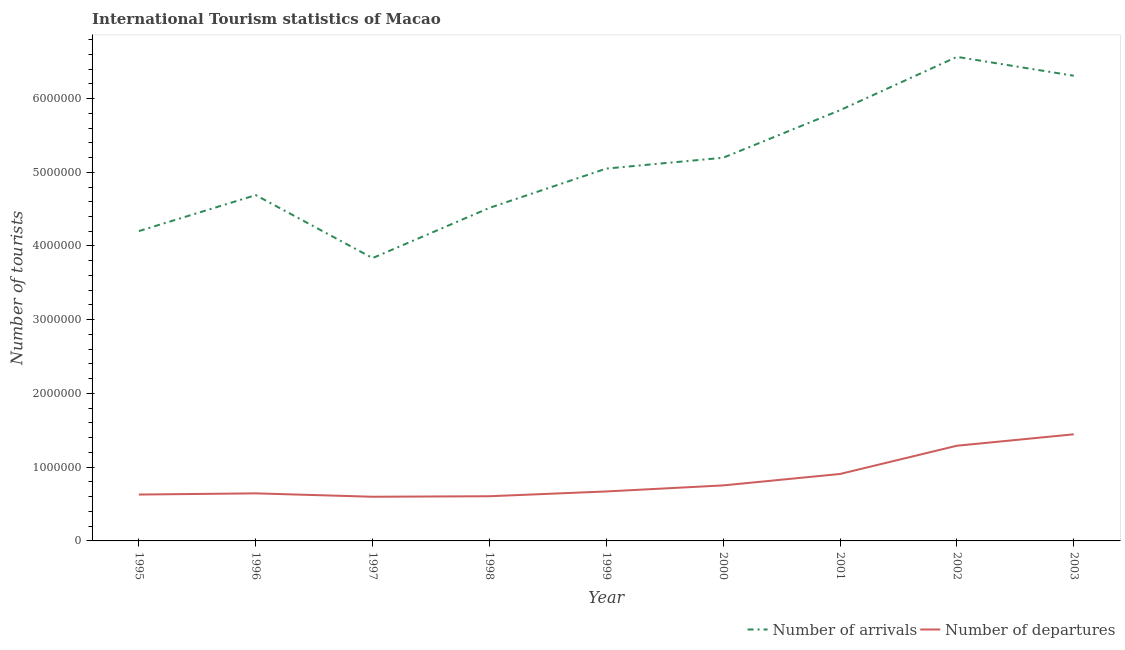How many different coloured lines are there?
Make the answer very short. 2. Does the line corresponding to number of tourist arrivals intersect with the line corresponding to number of tourist departures?
Offer a very short reply. No. What is the number of tourist arrivals in 1996?
Keep it short and to the point. 4.69e+06. Across all years, what is the maximum number of tourist arrivals?
Your answer should be compact. 6.56e+06. Across all years, what is the minimum number of tourist arrivals?
Give a very brief answer. 3.84e+06. In which year was the number of tourist arrivals maximum?
Keep it short and to the point. 2002. In which year was the number of tourist departures minimum?
Your response must be concise. 1997. What is the total number of tourist arrivals in the graph?
Make the answer very short. 4.62e+07. What is the difference between the number of tourist arrivals in 1995 and that in 1999?
Provide a succinct answer. -8.48e+05. What is the difference between the number of tourist arrivals in 1996 and the number of tourist departures in 1995?
Offer a terse response. 4.06e+06. What is the average number of tourist departures per year?
Your response must be concise. 8.39e+05. In the year 1997, what is the difference between the number of tourist departures and number of tourist arrivals?
Your answer should be very brief. -3.24e+06. In how many years, is the number of tourist departures greater than 1800000?
Your answer should be very brief. 0. What is the ratio of the number of tourist departures in 2000 to that in 2003?
Give a very brief answer. 0.52. Is the number of tourist departures in 1996 less than that in 2000?
Make the answer very short. Yes. What is the difference between the highest and the second highest number of tourist arrivals?
Provide a succinct answer. 2.56e+05. What is the difference between the highest and the lowest number of tourist departures?
Your answer should be compact. 8.47e+05. In how many years, is the number of tourist departures greater than the average number of tourist departures taken over all years?
Give a very brief answer. 3. Is the number of tourist departures strictly less than the number of tourist arrivals over the years?
Provide a succinct answer. Yes. What is the difference between two consecutive major ticks on the Y-axis?
Provide a short and direct response. 1.00e+06. Are the values on the major ticks of Y-axis written in scientific E-notation?
Provide a short and direct response. No. Does the graph contain any zero values?
Give a very brief answer. No. Where does the legend appear in the graph?
Your response must be concise. Bottom right. How many legend labels are there?
Offer a very short reply. 2. What is the title of the graph?
Keep it short and to the point. International Tourism statistics of Macao. Does "Infant" appear as one of the legend labels in the graph?
Make the answer very short. No. What is the label or title of the X-axis?
Offer a terse response. Year. What is the label or title of the Y-axis?
Offer a very short reply. Number of tourists. What is the Number of tourists of Number of arrivals in 1995?
Give a very brief answer. 4.20e+06. What is the Number of tourists of Number of departures in 1995?
Your answer should be compact. 6.29e+05. What is the Number of tourists in Number of arrivals in 1996?
Your answer should be compact. 4.69e+06. What is the Number of tourists of Number of departures in 1996?
Keep it short and to the point. 6.45e+05. What is the Number of tourists of Number of arrivals in 1997?
Provide a short and direct response. 3.84e+06. What is the Number of tourists of Number of departures in 1997?
Your answer should be compact. 5.99e+05. What is the Number of tourists in Number of arrivals in 1998?
Provide a succinct answer. 4.52e+06. What is the Number of tourists of Number of departures in 1998?
Provide a short and direct response. 6.06e+05. What is the Number of tourists of Number of arrivals in 1999?
Provide a succinct answer. 5.05e+06. What is the Number of tourists in Number of departures in 1999?
Make the answer very short. 6.71e+05. What is the Number of tourists of Number of arrivals in 2000?
Offer a very short reply. 5.20e+06. What is the Number of tourists in Number of departures in 2000?
Provide a short and direct response. 7.53e+05. What is the Number of tourists of Number of arrivals in 2001?
Provide a succinct answer. 5.84e+06. What is the Number of tourists of Number of departures in 2001?
Your answer should be compact. 9.08e+05. What is the Number of tourists in Number of arrivals in 2002?
Your answer should be very brief. 6.56e+06. What is the Number of tourists in Number of departures in 2002?
Make the answer very short. 1.29e+06. What is the Number of tourists of Number of arrivals in 2003?
Offer a very short reply. 6.31e+06. What is the Number of tourists of Number of departures in 2003?
Keep it short and to the point. 1.45e+06. Across all years, what is the maximum Number of tourists of Number of arrivals?
Offer a terse response. 6.56e+06. Across all years, what is the maximum Number of tourists of Number of departures?
Your answer should be very brief. 1.45e+06. Across all years, what is the minimum Number of tourists in Number of arrivals?
Keep it short and to the point. 3.84e+06. Across all years, what is the minimum Number of tourists of Number of departures?
Offer a very short reply. 5.99e+05. What is the total Number of tourists in Number of arrivals in the graph?
Your answer should be very brief. 4.62e+07. What is the total Number of tourists in Number of departures in the graph?
Keep it short and to the point. 7.55e+06. What is the difference between the Number of tourists in Number of arrivals in 1995 and that in 1996?
Provide a succinct answer. -4.88e+05. What is the difference between the Number of tourists of Number of departures in 1995 and that in 1996?
Your answer should be compact. -1.60e+04. What is the difference between the Number of tourists in Number of arrivals in 1995 and that in 1997?
Offer a terse response. 3.66e+05. What is the difference between the Number of tourists of Number of arrivals in 1995 and that in 1998?
Give a very brief answer. -3.15e+05. What is the difference between the Number of tourists of Number of departures in 1995 and that in 1998?
Ensure brevity in your answer.  2.30e+04. What is the difference between the Number of tourists of Number of arrivals in 1995 and that in 1999?
Your answer should be compact. -8.48e+05. What is the difference between the Number of tourists in Number of departures in 1995 and that in 1999?
Your response must be concise. -4.20e+04. What is the difference between the Number of tourists of Number of arrivals in 1995 and that in 2000?
Offer a very short reply. -9.95e+05. What is the difference between the Number of tourists of Number of departures in 1995 and that in 2000?
Offer a terse response. -1.24e+05. What is the difference between the Number of tourists in Number of arrivals in 1995 and that in 2001?
Your answer should be very brief. -1.64e+06. What is the difference between the Number of tourists in Number of departures in 1995 and that in 2001?
Your answer should be compact. -2.79e+05. What is the difference between the Number of tourists of Number of arrivals in 1995 and that in 2002?
Offer a very short reply. -2.36e+06. What is the difference between the Number of tourists of Number of departures in 1995 and that in 2002?
Your answer should be compact. -6.62e+05. What is the difference between the Number of tourists in Number of arrivals in 1995 and that in 2003?
Your answer should be compact. -2.11e+06. What is the difference between the Number of tourists in Number of departures in 1995 and that in 2003?
Your answer should be compact. -8.17e+05. What is the difference between the Number of tourists of Number of arrivals in 1996 and that in 1997?
Provide a succinct answer. 8.54e+05. What is the difference between the Number of tourists of Number of departures in 1996 and that in 1997?
Your answer should be very brief. 4.60e+04. What is the difference between the Number of tourists of Number of arrivals in 1996 and that in 1998?
Provide a short and direct response. 1.73e+05. What is the difference between the Number of tourists in Number of departures in 1996 and that in 1998?
Your answer should be very brief. 3.90e+04. What is the difference between the Number of tourists of Number of arrivals in 1996 and that in 1999?
Your answer should be compact. -3.60e+05. What is the difference between the Number of tourists in Number of departures in 1996 and that in 1999?
Offer a very short reply. -2.60e+04. What is the difference between the Number of tourists in Number of arrivals in 1996 and that in 2000?
Provide a succinct answer. -5.07e+05. What is the difference between the Number of tourists in Number of departures in 1996 and that in 2000?
Make the answer very short. -1.08e+05. What is the difference between the Number of tourists of Number of arrivals in 1996 and that in 2001?
Offer a very short reply. -1.15e+06. What is the difference between the Number of tourists of Number of departures in 1996 and that in 2001?
Offer a terse response. -2.63e+05. What is the difference between the Number of tourists in Number of arrivals in 1996 and that in 2002?
Your answer should be very brief. -1.88e+06. What is the difference between the Number of tourists of Number of departures in 1996 and that in 2002?
Keep it short and to the point. -6.46e+05. What is the difference between the Number of tourists in Number of arrivals in 1996 and that in 2003?
Your response must be concise. -1.62e+06. What is the difference between the Number of tourists of Number of departures in 1996 and that in 2003?
Keep it short and to the point. -8.01e+05. What is the difference between the Number of tourists in Number of arrivals in 1997 and that in 1998?
Provide a short and direct response. -6.81e+05. What is the difference between the Number of tourists of Number of departures in 1997 and that in 1998?
Provide a succinct answer. -7000. What is the difference between the Number of tourists of Number of arrivals in 1997 and that in 1999?
Your answer should be compact. -1.21e+06. What is the difference between the Number of tourists of Number of departures in 1997 and that in 1999?
Offer a very short reply. -7.20e+04. What is the difference between the Number of tourists in Number of arrivals in 1997 and that in 2000?
Ensure brevity in your answer.  -1.36e+06. What is the difference between the Number of tourists of Number of departures in 1997 and that in 2000?
Your answer should be very brief. -1.54e+05. What is the difference between the Number of tourists in Number of arrivals in 1997 and that in 2001?
Provide a succinct answer. -2.01e+06. What is the difference between the Number of tourists in Number of departures in 1997 and that in 2001?
Ensure brevity in your answer.  -3.09e+05. What is the difference between the Number of tourists in Number of arrivals in 1997 and that in 2002?
Keep it short and to the point. -2.73e+06. What is the difference between the Number of tourists in Number of departures in 1997 and that in 2002?
Your answer should be very brief. -6.92e+05. What is the difference between the Number of tourists in Number of arrivals in 1997 and that in 2003?
Ensure brevity in your answer.  -2.47e+06. What is the difference between the Number of tourists in Number of departures in 1997 and that in 2003?
Provide a short and direct response. -8.47e+05. What is the difference between the Number of tourists in Number of arrivals in 1998 and that in 1999?
Provide a succinct answer. -5.33e+05. What is the difference between the Number of tourists in Number of departures in 1998 and that in 1999?
Offer a very short reply. -6.50e+04. What is the difference between the Number of tourists of Number of arrivals in 1998 and that in 2000?
Keep it short and to the point. -6.80e+05. What is the difference between the Number of tourists in Number of departures in 1998 and that in 2000?
Your answer should be very brief. -1.47e+05. What is the difference between the Number of tourists in Number of arrivals in 1998 and that in 2001?
Your answer should be compact. -1.32e+06. What is the difference between the Number of tourists of Number of departures in 1998 and that in 2001?
Provide a succinct answer. -3.02e+05. What is the difference between the Number of tourists of Number of arrivals in 1998 and that in 2002?
Ensure brevity in your answer.  -2.05e+06. What is the difference between the Number of tourists in Number of departures in 1998 and that in 2002?
Make the answer very short. -6.85e+05. What is the difference between the Number of tourists of Number of arrivals in 1998 and that in 2003?
Ensure brevity in your answer.  -1.79e+06. What is the difference between the Number of tourists of Number of departures in 1998 and that in 2003?
Provide a succinct answer. -8.40e+05. What is the difference between the Number of tourists of Number of arrivals in 1999 and that in 2000?
Your answer should be compact. -1.47e+05. What is the difference between the Number of tourists of Number of departures in 1999 and that in 2000?
Your answer should be compact. -8.20e+04. What is the difference between the Number of tourists in Number of arrivals in 1999 and that in 2001?
Offer a terse response. -7.92e+05. What is the difference between the Number of tourists in Number of departures in 1999 and that in 2001?
Your answer should be compact. -2.37e+05. What is the difference between the Number of tourists of Number of arrivals in 1999 and that in 2002?
Provide a short and direct response. -1.52e+06. What is the difference between the Number of tourists in Number of departures in 1999 and that in 2002?
Offer a very short reply. -6.20e+05. What is the difference between the Number of tourists of Number of arrivals in 1999 and that in 2003?
Provide a short and direct response. -1.26e+06. What is the difference between the Number of tourists of Number of departures in 1999 and that in 2003?
Ensure brevity in your answer.  -7.75e+05. What is the difference between the Number of tourists in Number of arrivals in 2000 and that in 2001?
Provide a short and direct response. -6.45e+05. What is the difference between the Number of tourists in Number of departures in 2000 and that in 2001?
Your answer should be very brief. -1.55e+05. What is the difference between the Number of tourists of Number of arrivals in 2000 and that in 2002?
Make the answer very short. -1.37e+06. What is the difference between the Number of tourists of Number of departures in 2000 and that in 2002?
Give a very brief answer. -5.38e+05. What is the difference between the Number of tourists of Number of arrivals in 2000 and that in 2003?
Provide a succinct answer. -1.11e+06. What is the difference between the Number of tourists in Number of departures in 2000 and that in 2003?
Ensure brevity in your answer.  -6.93e+05. What is the difference between the Number of tourists of Number of arrivals in 2001 and that in 2002?
Provide a succinct answer. -7.23e+05. What is the difference between the Number of tourists in Number of departures in 2001 and that in 2002?
Your answer should be very brief. -3.83e+05. What is the difference between the Number of tourists in Number of arrivals in 2001 and that in 2003?
Give a very brief answer. -4.67e+05. What is the difference between the Number of tourists of Number of departures in 2001 and that in 2003?
Give a very brief answer. -5.38e+05. What is the difference between the Number of tourists in Number of arrivals in 2002 and that in 2003?
Give a very brief answer. 2.56e+05. What is the difference between the Number of tourists of Number of departures in 2002 and that in 2003?
Your answer should be very brief. -1.55e+05. What is the difference between the Number of tourists in Number of arrivals in 1995 and the Number of tourists in Number of departures in 1996?
Keep it short and to the point. 3.56e+06. What is the difference between the Number of tourists in Number of arrivals in 1995 and the Number of tourists in Number of departures in 1997?
Give a very brief answer. 3.60e+06. What is the difference between the Number of tourists of Number of arrivals in 1995 and the Number of tourists of Number of departures in 1998?
Ensure brevity in your answer.  3.60e+06. What is the difference between the Number of tourists of Number of arrivals in 1995 and the Number of tourists of Number of departures in 1999?
Provide a succinct answer. 3.53e+06. What is the difference between the Number of tourists of Number of arrivals in 1995 and the Number of tourists of Number of departures in 2000?
Offer a very short reply. 3.45e+06. What is the difference between the Number of tourists of Number of arrivals in 1995 and the Number of tourists of Number of departures in 2001?
Your answer should be very brief. 3.29e+06. What is the difference between the Number of tourists in Number of arrivals in 1995 and the Number of tourists in Number of departures in 2002?
Provide a short and direct response. 2.91e+06. What is the difference between the Number of tourists in Number of arrivals in 1995 and the Number of tourists in Number of departures in 2003?
Make the answer very short. 2.76e+06. What is the difference between the Number of tourists in Number of arrivals in 1996 and the Number of tourists in Number of departures in 1997?
Your response must be concise. 4.09e+06. What is the difference between the Number of tourists in Number of arrivals in 1996 and the Number of tourists in Number of departures in 1998?
Offer a very short reply. 4.08e+06. What is the difference between the Number of tourists in Number of arrivals in 1996 and the Number of tourists in Number of departures in 1999?
Your response must be concise. 4.02e+06. What is the difference between the Number of tourists in Number of arrivals in 1996 and the Number of tourists in Number of departures in 2000?
Ensure brevity in your answer.  3.94e+06. What is the difference between the Number of tourists of Number of arrivals in 1996 and the Number of tourists of Number of departures in 2001?
Provide a succinct answer. 3.78e+06. What is the difference between the Number of tourists of Number of arrivals in 1996 and the Number of tourists of Number of departures in 2002?
Your response must be concise. 3.40e+06. What is the difference between the Number of tourists of Number of arrivals in 1996 and the Number of tourists of Number of departures in 2003?
Provide a succinct answer. 3.24e+06. What is the difference between the Number of tourists in Number of arrivals in 1997 and the Number of tourists in Number of departures in 1998?
Offer a very short reply. 3.23e+06. What is the difference between the Number of tourists of Number of arrivals in 1997 and the Number of tourists of Number of departures in 1999?
Provide a succinct answer. 3.16e+06. What is the difference between the Number of tourists in Number of arrivals in 1997 and the Number of tourists in Number of departures in 2000?
Provide a short and direct response. 3.08e+06. What is the difference between the Number of tourists of Number of arrivals in 1997 and the Number of tourists of Number of departures in 2001?
Ensure brevity in your answer.  2.93e+06. What is the difference between the Number of tourists in Number of arrivals in 1997 and the Number of tourists in Number of departures in 2002?
Your response must be concise. 2.54e+06. What is the difference between the Number of tourists in Number of arrivals in 1997 and the Number of tourists in Number of departures in 2003?
Provide a succinct answer. 2.39e+06. What is the difference between the Number of tourists in Number of arrivals in 1998 and the Number of tourists in Number of departures in 1999?
Your answer should be compact. 3.85e+06. What is the difference between the Number of tourists in Number of arrivals in 1998 and the Number of tourists in Number of departures in 2000?
Provide a succinct answer. 3.76e+06. What is the difference between the Number of tourists of Number of arrivals in 1998 and the Number of tourists of Number of departures in 2001?
Make the answer very short. 3.61e+06. What is the difference between the Number of tourists in Number of arrivals in 1998 and the Number of tourists in Number of departures in 2002?
Provide a short and direct response. 3.23e+06. What is the difference between the Number of tourists of Number of arrivals in 1998 and the Number of tourists of Number of departures in 2003?
Make the answer very short. 3.07e+06. What is the difference between the Number of tourists in Number of arrivals in 1999 and the Number of tourists in Number of departures in 2000?
Ensure brevity in your answer.  4.30e+06. What is the difference between the Number of tourists in Number of arrivals in 1999 and the Number of tourists in Number of departures in 2001?
Keep it short and to the point. 4.14e+06. What is the difference between the Number of tourists of Number of arrivals in 1999 and the Number of tourists of Number of departures in 2002?
Provide a succinct answer. 3.76e+06. What is the difference between the Number of tourists of Number of arrivals in 1999 and the Number of tourists of Number of departures in 2003?
Your answer should be compact. 3.60e+06. What is the difference between the Number of tourists of Number of arrivals in 2000 and the Number of tourists of Number of departures in 2001?
Provide a succinct answer. 4.29e+06. What is the difference between the Number of tourists in Number of arrivals in 2000 and the Number of tourists in Number of departures in 2002?
Provide a succinct answer. 3.91e+06. What is the difference between the Number of tourists of Number of arrivals in 2000 and the Number of tourists of Number of departures in 2003?
Provide a short and direct response. 3.75e+06. What is the difference between the Number of tourists of Number of arrivals in 2001 and the Number of tourists of Number of departures in 2002?
Give a very brief answer. 4.55e+06. What is the difference between the Number of tourists in Number of arrivals in 2001 and the Number of tourists in Number of departures in 2003?
Your response must be concise. 4.40e+06. What is the difference between the Number of tourists in Number of arrivals in 2002 and the Number of tourists in Number of departures in 2003?
Make the answer very short. 5.12e+06. What is the average Number of tourists in Number of arrivals per year?
Offer a very short reply. 5.13e+06. What is the average Number of tourists of Number of departures per year?
Ensure brevity in your answer.  8.39e+05. In the year 1995, what is the difference between the Number of tourists of Number of arrivals and Number of tourists of Number of departures?
Give a very brief answer. 3.57e+06. In the year 1996, what is the difference between the Number of tourists in Number of arrivals and Number of tourists in Number of departures?
Keep it short and to the point. 4.04e+06. In the year 1997, what is the difference between the Number of tourists of Number of arrivals and Number of tourists of Number of departures?
Your answer should be compact. 3.24e+06. In the year 1998, what is the difference between the Number of tourists of Number of arrivals and Number of tourists of Number of departures?
Your response must be concise. 3.91e+06. In the year 1999, what is the difference between the Number of tourists in Number of arrivals and Number of tourists in Number of departures?
Provide a short and direct response. 4.38e+06. In the year 2000, what is the difference between the Number of tourists of Number of arrivals and Number of tourists of Number of departures?
Offer a very short reply. 4.44e+06. In the year 2001, what is the difference between the Number of tourists in Number of arrivals and Number of tourists in Number of departures?
Make the answer very short. 4.93e+06. In the year 2002, what is the difference between the Number of tourists in Number of arrivals and Number of tourists in Number of departures?
Offer a terse response. 5.27e+06. In the year 2003, what is the difference between the Number of tourists in Number of arrivals and Number of tourists in Number of departures?
Your answer should be very brief. 4.86e+06. What is the ratio of the Number of tourists of Number of arrivals in 1995 to that in 1996?
Offer a terse response. 0.9. What is the ratio of the Number of tourists of Number of departures in 1995 to that in 1996?
Your response must be concise. 0.98. What is the ratio of the Number of tourists in Number of arrivals in 1995 to that in 1997?
Provide a short and direct response. 1.1. What is the ratio of the Number of tourists of Number of departures in 1995 to that in 1997?
Provide a succinct answer. 1.05. What is the ratio of the Number of tourists of Number of arrivals in 1995 to that in 1998?
Your answer should be compact. 0.93. What is the ratio of the Number of tourists of Number of departures in 1995 to that in 1998?
Keep it short and to the point. 1.04. What is the ratio of the Number of tourists of Number of arrivals in 1995 to that in 1999?
Offer a terse response. 0.83. What is the ratio of the Number of tourists in Number of departures in 1995 to that in 1999?
Offer a very short reply. 0.94. What is the ratio of the Number of tourists in Number of arrivals in 1995 to that in 2000?
Your answer should be very brief. 0.81. What is the ratio of the Number of tourists in Number of departures in 1995 to that in 2000?
Your answer should be compact. 0.84. What is the ratio of the Number of tourists of Number of arrivals in 1995 to that in 2001?
Offer a terse response. 0.72. What is the ratio of the Number of tourists in Number of departures in 1995 to that in 2001?
Give a very brief answer. 0.69. What is the ratio of the Number of tourists in Number of arrivals in 1995 to that in 2002?
Your response must be concise. 0.64. What is the ratio of the Number of tourists of Number of departures in 1995 to that in 2002?
Your answer should be very brief. 0.49. What is the ratio of the Number of tourists of Number of arrivals in 1995 to that in 2003?
Give a very brief answer. 0.67. What is the ratio of the Number of tourists in Number of departures in 1995 to that in 2003?
Make the answer very short. 0.43. What is the ratio of the Number of tourists of Number of arrivals in 1996 to that in 1997?
Your answer should be compact. 1.22. What is the ratio of the Number of tourists in Number of departures in 1996 to that in 1997?
Keep it short and to the point. 1.08. What is the ratio of the Number of tourists in Number of arrivals in 1996 to that in 1998?
Keep it short and to the point. 1.04. What is the ratio of the Number of tourists of Number of departures in 1996 to that in 1998?
Your answer should be very brief. 1.06. What is the ratio of the Number of tourists of Number of arrivals in 1996 to that in 1999?
Give a very brief answer. 0.93. What is the ratio of the Number of tourists of Number of departures in 1996 to that in 1999?
Give a very brief answer. 0.96. What is the ratio of the Number of tourists of Number of arrivals in 1996 to that in 2000?
Your answer should be very brief. 0.9. What is the ratio of the Number of tourists in Number of departures in 1996 to that in 2000?
Provide a short and direct response. 0.86. What is the ratio of the Number of tourists in Number of arrivals in 1996 to that in 2001?
Provide a succinct answer. 0.8. What is the ratio of the Number of tourists of Number of departures in 1996 to that in 2001?
Make the answer very short. 0.71. What is the ratio of the Number of tourists of Number of arrivals in 1996 to that in 2002?
Provide a succinct answer. 0.71. What is the ratio of the Number of tourists in Number of departures in 1996 to that in 2002?
Offer a very short reply. 0.5. What is the ratio of the Number of tourists of Number of arrivals in 1996 to that in 2003?
Keep it short and to the point. 0.74. What is the ratio of the Number of tourists of Number of departures in 1996 to that in 2003?
Give a very brief answer. 0.45. What is the ratio of the Number of tourists in Number of arrivals in 1997 to that in 1998?
Keep it short and to the point. 0.85. What is the ratio of the Number of tourists of Number of departures in 1997 to that in 1998?
Give a very brief answer. 0.99. What is the ratio of the Number of tourists of Number of arrivals in 1997 to that in 1999?
Offer a terse response. 0.76. What is the ratio of the Number of tourists of Number of departures in 1997 to that in 1999?
Ensure brevity in your answer.  0.89. What is the ratio of the Number of tourists in Number of arrivals in 1997 to that in 2000?
Your response must be concise. 0.74. What is the ratio of the Number of tourists in Number of departures in 1997 to that in 2000?
Provide a succinct answer. 0.8. What is the ratio of the Number of tourists of Number of arrivals in 1997 to that in 2001?
Ensure brevity in your answer.  0.66. What is the ratio of the Number of tourists in Number of departures in 1997 to that in 2001?
Keep it short and to the point. 0.66. What is the ratio of the Number of tourists in Number of arrivals in 1997 to that in 2002?
Provide a succinct answer. 0.58. What is the ratio of the Number of tourists in Number of departures in 1997 to that in 2002?
Keep it short and to the point. 0.46. What is the ratio of the Number of tourists in Number of arrivals in 1997 to that in 2003?
Keep it short and to the point. 0.61. What is the ratio of the Number of tourists of Number of departures in 1997 to that in 2003?
Your answer should be very brief. 0.41. What is the ratio of the Number of tourists of Number of arrivals in 1998 to that in 1999?
Give a very brief answer. 0.89. What is the ratio of the Number of tourists of Number of departures in 1998 to that in 1999?
Your response must be concise. 0.9. What is the ratio of the Number of tourists in Number of arrivals in 1998 to that in 2000?
Make the answer very short. 0.87. What is the ratio of the Number of tourists in Number of departures in 1998 to that in 2000?
Provide a short and direct response. 0.8. What is the ratio of the Number of tourists in Number of arrivals in 1998 to that in 2001?
Offer a very short reply. 0.77. What is the ratio of the Number of tourists in Number of departures in 1998 to that in 2001?
Offer a very short reply. 0.67. What is the ratio of the Number of tourists of Number of arrivals in 1998 to that in 2002?
Provide a succinct answer. 0.69. What is the ratio of the Number of tourists in Number of departures in 1998 to that in 2002?
Give a very brief answer. 0.47. What is the ratio of the Number of tourists of Number of arrivals in 1998 to that in 2003?
Your answer should be compact. 0.72. What is the ratio of the Number of tourists of Number of departures in 1998 to that in 2003?
Provide a short and direct response. 0.42. What is the ratio of the Number of tourists in Number of arrivals in 1999 to that in 2000?
Provide a succinct answer. 0.97. What is the ratio of the Number of tourists in Number of departures in 1999 to that in 2000?
Your answer should be compact. 0.89. What is the ratio of the Number of tourists of Number of arrivals in 1999 to that in 2001?
Make the answer very short. 0.86. What is the ratio of the Number of tourists of Number of departures in 1999 to that in 2001?
Offer a very short reply. 0.74. What is the ratio of the Number of tourists of Number of arrivals in 1999 to that in 2002?
Provide a short and direct response. 0.77. What is the ratio of the Number of tourists of Number of departures in 1999 to that in 2002?
Provide a succinct answer. 0.52. What is the ratio of the Number of tourists in Number of arrivals in 1999 to that in 2003?
Your response must be concise. 0.8. What is the ratio of the Number of tourists of Number of departures in 1999 to that in 2003?
Provide a succinct answer. 0.46. What is the ratio of the Number of tourists in Number of arrivals in 2000 to that in 2001?
Your answer should be compact. 0.89. What is the ratio of the Number of tourists in Number of departures in 2000 to that in 2001?
Make the answer very short. 0.83. What is the ratio of the Number of tourists of Number of arrivals in 2000 to that in 2002?
Offer a very short reply. 0.79. What is the ratio of the Number of tourists of Number of departures in 2000 to that in 2002?
Provide a succinct answer. 0.58. What is the ratio of the Number of tourists of Number of arrivals in 2000 to that in 2003?
Provide a succinct answer. 0.82. What is the ratio of the Number of tourists of Number of departures in 2000 to that in 2003?
Make the answer very short. 0.52. What is the ratio of the Number of tourists in Number of arrivals in 2001 to that in 2002?
Provide a short and direct response. 0.89. What is the ratio of the Number of tourists of Number of departures in 2001 to that in 2002?
Offer a terse response. 0.7. What is the ratio of the Number of tourists of Number of arrivals in 2001 to that in 2003?
Your answer should be compact. 0.93. What is the ratio of the Number of tourists in Number of departures in 2001 to that in 2003?
Your answer should be compact. 0.63. What is the ratio of the Number of tourists of Number of arrivals in 2002 to that in 2003?
Ensure brevity in your answer.  1.04. What is the ratio of the Number of tourists in Number of departures in 2002 to that in 2003?
Provide a succinct answer. 0.89. What is the difference between the highest and the second highest Number of tourists in Number of arrivals?
Offer a terse response. 2.56e+05. What is the difference between the highest and the second highest Number of tourists in Number of departures?
Your response must be concise. 1.55e+05. What is the difference between the highest and the lowest Number of tourists of Number of arrivals?
Offer a terse response. 2.73e+06. What is the difference between the highest and the lowest Number of tourists of Number of departures?
Provide a succinct answer. 8.47e+05. 